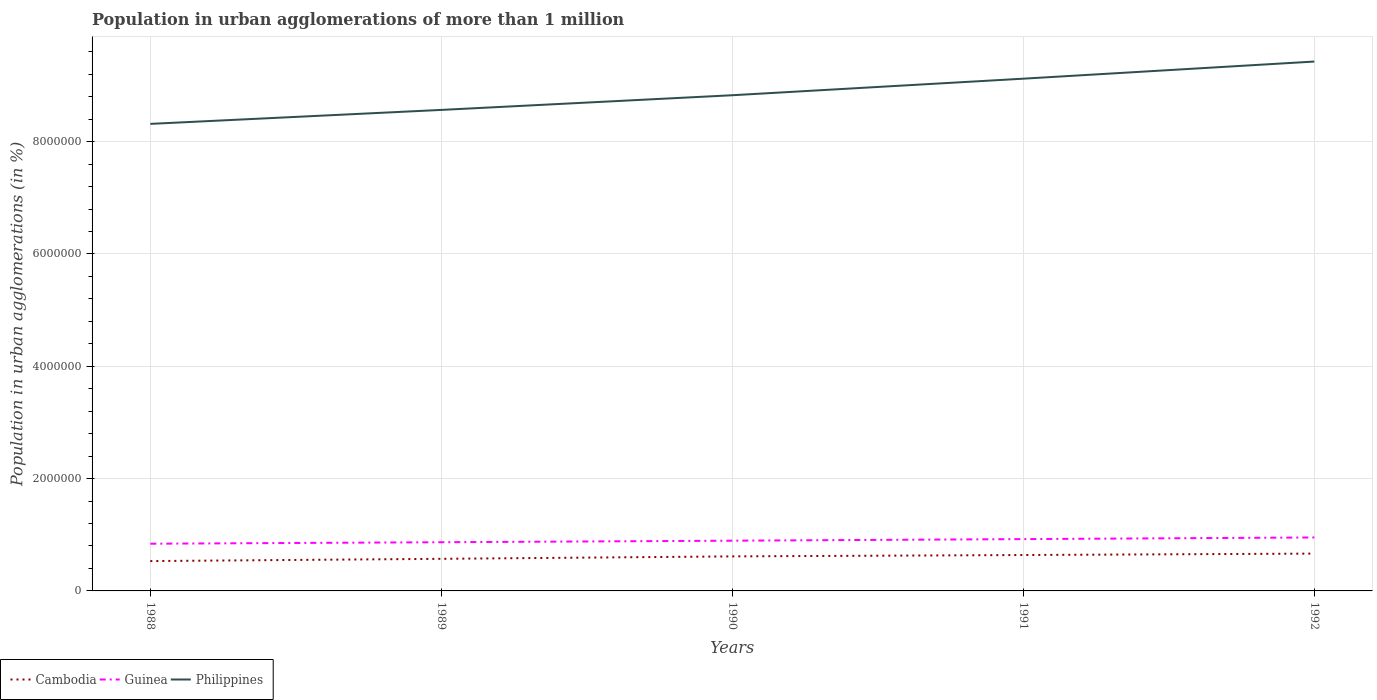How many different coloured lines are there?
Offer a very short reply. 3. Across all years, what is the maximum population in urban agglomerations in Guinea?
Make the answer very short. 8.41e+05. In which year was the population in urban agglomerations in Cambodia maximum?
Keep it short and to the point. 1988. What is the total population in urban agglomerations in Philippines in the graph?
Make the answer very short. -5.56e+05. What is the difference between the highest and the second highest population in urban agglomerations in Guinea?
Your answer should be compact. 1.11e+05. How many lines are there?
Offer a terse response. 3. How many years are there in the graph?
Your answer should be very brief. 5. What is the difference between two consecutive major ticks on the Y-axis?
Give a very brief answer. 2.00e+06. Are the values on the major ticks of Y-axis written in scientific E-notation?
Ensure brevity in your answer.  No. Does the graph contain any zero values?
Offer a terse response. No. How many legend labels are there?
Your response must be concise. 3. How are the legend labels stacked?
Offer a very short reply. Horizontal. What is the title of the graph?
Your answer should be very brief. Population in urban agglomerations of more than 1 million. What is the label or title of the X-axis?
Your response must be concise. Years. What is the label or title of the Y-axis?
Make the answer very short. Population in urban agglomerations (in %). What is the Population in urban agglomerations (in %) of Cambodia in 1988?
Your response must be concise. 5.32e+05. What is the Population in urban agglomerations (in %) in Guinea in 1988?
Provide a short and direct response. 8.41e+05. What is the Population in urban agglomerations (in %) of Philippines in 1988?
Your answer should be compact. 8.32e+06. What is the Population in urban agglomerations (in %) in Cambodia in 1989?
Give a very brief answer. 5.72e+05. What is the Population in urban agglomerations (in %) of Guinea in 1989?
Your answer should be compact. 8.67e+05. What is the Population in urban agglomerations (in %) of Philippines in 1989?
Give a very brief answer. 8.57e+06. What is the Population in urban agglomerations (in %) in Cambodia in 1990?
Keep it short and to the point. 6.15e+05. What is the Population in urban agglomerations (in %) of Guinea in 1990?
Provide a short and direct response. 8.95e+05. What is the Population in urban agglomerations (in %) in Philippines in 1990?
Keep it short and to the point. 8.83e+06. What is the Population in urban agglomerations (in %) in Cambodia in 1991?
Make the answer very short. 6.39e+05. What is the Population in urban agglomerations (in %) of Guinea in 1991?
Give a very brief answer. 9.23e+05. What is the Population in urban agglomerations (in %) of Philippines in 1991?
Keep it short and to the point. 9.12e+06. What is the Population in urban agglomerations (in %) in Cambodia in 1992?
Your response must be concise. 6.65e+05. What is the Population in urban agglomerations (in %) of Guinea in 1992?
Make the answer very short. 9.52e+05. What is the Population in urban agglomerations (in %) of Philippines in 1992?
Offer a very short reply. 9.43e+06. Across all years, what is the maximum Population in urban agglomerations (in %) in Cambodia?
Provide a succinct answer. 6.65e+05. Across all years, what is the maximum Population in urban agglomerations (in %) in Guinea?
Offer a terse response. 9.52e+05. Across all years, what is the maximum Population in urban agglomerations (in %) of Philippines?
Make the answer very short. 9.43e+06. Across all years, what is the minimum Population in urban agglomerations (in %) of Cambodia?
Provide a succinct answer. 5.32e+05. Across all years, what is the minimum Population in urban agglomerations (in %) in Guinea?
Your answer should be very brief. 8.41e+05. Across all years, what is the minimum Population in urban agglomerations (in %) in Philippines?
Offer a very short reply. 8.32e+06. What is the total Population in urban agglomerations (in %) of Cambodia in the graph?
Ensure brevity in your answer.  3.02e+06. What is the total Population in urban agglomerations (in %) of Guinea in the graph?
Provide a succinct answer. 4.48e+06. What is the total Population in urban agglomerations (in %) in Philippines in the graph?
Provide a short and direct response. 4.43e+07. What is the difference between the Population in urban agglomerations (in %) of Cambodia in 1988 and that in 1989?
Ensure brevity in your answer.  -4.02e+04. What is the difference between the Population in urban agglomerations (in %) in Guinea in 1988 and that in 1989?
Offer a terse response. -2.65e+04. What is the difference between the Population in urban agglomerations (in %) in Philippines in 1988 and that in 1989?
Provide a succinct answer. -2.49e+05. What is the difference between the Population in urban agglomerations (in %) in Cambodia in 1988 and that in 1990?
Give a very brief answer. -8.35e+04. What is the difference between the Population in urban agglomerations (in %) of Guinea in 1988 and that in 1990?
Keep it short and to the point. -5.39e+04. What is the difference between the Population in urban agglomerations (in %) of Philippines in 1988 and that in 1990?
Keep it short and to the point. -5.10e+05. What is the difference between the Population in urban agglomerations (in %) of Cambodia in 1988 and that in 1991?
Your response must be concise. -1.08e+05. What is the difference between the Population in urban agglomerations (in %) of Guinea in 1988 and that in 1991?
Make the answer very short. -8.22e+04. What is the difference between the Population in urban agglomerations (in %) of Philippines in 1988 and that in 1991?
Offer a terse response. -8.05e+05. What is the difference between the Population in urban agglomerations (in %) in Cambodia in 1988 and that in 1992?
Make the answer very short. -1.33e+05. What is the difference between the Population in urban agglomerations (in %) of Guinea in 1988 and that in 1992?
Offer a very short reply. -1.11e+05. What is the difference between the Population in urban agglomerations (in %) in Philippines in 1988 and that in 1992?
Offer a terse response. -1.11e+06. What is the difference between the Population in urban agglomerations (in %) in Cambodia in 1989 and that in 1990?
Ensure brevity in your answer.  -4.33e+04. What is the difference between the Population in urban agglomerations (in %) of Guinea in 1989 and that in 1990?
Keep it short and to the point. -2.74e+04. What is the difference between the Population in urban agglomerations (in %) in Philippines in 1989 and that in 1990?
Keep it short and to the point. -2.61e+05. What is the difference between the Population in urban agglomerations (in %) in Cambodia in 1989 and that in 1991?
Make the answer very short. -6.76e+04. What is the difference between the Population in urban agglomerations (in %) of Guinea in 1989 and that in 1991?
Your answer should be very brief. -5.57e+04. What is the difference between the Population in urban agglomerations (in %) of Philippines in 1989 and that in 1991?
Give a very brief answer. -5.56e+05. What is the difference between the Population in urban agglomerations (in %) of Cambodia in 1989 and that in 1992?
Offer a terse response. -9.30e+04. What is the difference between the Population in urban agglomerations (in %) of Guinea in 1989 and that in 1992?
Give a very brief answer. -8.49e+04. What is the difference between the Population in urban agglomerations (in %) in Philippines in 1989 and that in 1992?
Offer a terse response. -8.61e+05. What is the difference between the Population in urban agglomerations (in %) in Cambodia in 1990 and that in 1991?
Your answer should be compact. -2.44e+04. What is the difference between the Population in urban agglomerations (in %) in Guinea in 1990 and that in 1991?
Your answer should be compact. -2.83e+04. What is the difference between the Population in urban agglomerations (in %) of Philippines in 1990 and that in 1991?
Keep it short and to the point. -2.95e+05. What is the difference between the Population in urban agglomerations (in %) in Cambodia in 1990 and that in 1992?
Offer a terse response. -4.97e+04. What is the difference between the Population in urban agglomerations (in %) in Guinea in 1990 and that in 1992?
Provide a short and direct response. -5.75e+04. What is the difference between the Population in urban agglomerations (in %) in Philippines in 1990 and that in 1992?
Your answer should be very brief. -6.00e+05. What is the difference between the Population in urban agglomerations (in %) in Cambodia in 1991 and that in 1992?
Ensure brevity in your answer.  -2.54e+04. What is the difference between the Population in urban agglomerations (in %) of Guinea in 1991 and that in 1992?
Provide a short and direct response. -2.92e+04. What is the difference between the Population in urban agglomerations (in %) of Philippines in 1991 and that in 1992?
Your response must be concise. -3.05e+05. What is the difference between the Population in urban agglomerations (in %) of Cambodia in 1988 and the Population in urban agglomerations (in %) of Guinea in 1989?
Offer a very short reply. -3.36e+05. What is the difference between the Population in urban agglomerations (in %) of Cambodia in 1988 and the Population in urban agglomerations (in %) of Philippines in 1989?
Offer a very short reply. -8.03e+06. What is the difference between the Population in urban agglomerations (in %) of Guinea in 1988 and the Population in urban agglomerations (in %) of Philippines in 1989?
Offer a very short reply. -7.73e+06. What is the difference between the Population in urban agglomerations (in %) of Cambodia in 1988 and the Population in urban agglomerations (in %) of Guinea in 1990?
Your answer should be very brief. -3.63e+05. What is the difference between the Population in urban agglomerations (in %) in Cambodia in 1988 and the Population in urban agglomerations (in %) in Philippines in 1990?
Make the answer very short. -8.30e+06. What is the difference between the Population in urban agglomerations (in %) of Guinea in 1988 and the Population in urban agglomerations (in %) of Philippines in 1990?
Your answer should be very brief. -7.99e+06. What is the difference between the Population in urban agglomerations (in %) of Cambodia in 1988 and the Population in urban agglomerations (in %) of Guinea in 1991?
Make the answer very short. -3.91e+05. What is the difference between the Population in urban agglomerations (in %) of Cambodia in 1988 and the Population in urban agglomerations (in %) of Philippines in 1991?
Keep it short and to the point. -8.59e+06. What is the difference between the Population in urban agglomerations (in %) of Guinea in 1988 and the Population in urban agglomerations (in %) of Philippines in 1991?
Your answer should be very brief. -8.28e+06. What is the difference between the Population in urban agglomerations (in %) in Cambodia in 1988 and the Population in urban agglomerations (in %) in Guinea in 1992?
Your response must be concise. -4.20e+05. What is the difference between the Population in urban agglomerations (in %) of Cambodia in 1988 and the Population in urban agglomerations (in %) of Philippines in 1992?
Make the answer very short. -8.90e+06. What is the difference between the Population in urban agglomerations (in %) in Guinea in 1988 and the Population in urban agglomerations (in %) in Philippines in 1992?
Keep it short and to the point. -8.59e+06. What is the difference between the Population in urban agglomerations (in %) of Cambodia in 1989 and the Population in urban agglomerations (in %) of Guinea in 1990?
Offer a very short reply. -3.23e+05. What is the difference between the Population in urban agglomerations (in %) in Cambodia in 1989 and the Population in urban agglomerations (in %) in Philippines in 1990?
Ensure brevity in your answer.  -8.26e+06. What is the difference between the Population in urban agglomerations (in %) in Guinea in 1989 and the Population in urban agglomerations (in %) in Philippines in 1990?
Make the answer very short. -7.96e+06. What is the difference between the Population in urban agglomerations (in %) in Cambodia in 1989 and the Population in urban agglomerations (in %) in Guinea in 1991?
Provide a short and direct response. -3.51e+05. What is the difference between the Population in urban agglomerations (in %) of Cambodia in 1989 and the Population in urban agglomerations (in %) of Philippines in 1991?
Keep it short and to the point. -8.55e+06. What is the difference between the Population in urban agglomerations (in %) in Guinea in 1989 and the Population in urban agglomerations (in %) in Philippines in 1991?
Offer a very short reply. -8.25e+06. What is the difference between the Population in urban agglomerations (in %) of Cambodia in 1989 and the Population in urban agglomerations (in %) of Guinea in 1992?
Provide a short and direct response. -3.80e+05. What is the difference between the Population in urban agglomerations (in %) in Cambodia in 1989 and the Population in urban agglomerations (in %) in Philippines in 1992?
Your answer should be very brief. -8.86e+06. What is the difference between the Population in urban agglomerations (in %) of Guinea in 1989 and the Population in urban agglomerations (in %) of Philippines in 1992?
Offer a terse response. -8.56e+06. What is the difference between the Population in urban agglomerations (in %) in Cambodia in 1990 and the Population in urban agglomerations (in %) in Guinea in 1991?
Offer a terse response. -3.08e+05. What is the difference between the Population in urban agglomerations (in %) in Cambodia in 1990 and the Population in urban agglomerations (in %) in Philippines in 1991?
Ensure brevity in your answer.  -8.51e+06. What is the difference between the Population in urban agglomerations (in %) of Guinea in 1990 and the Population in urban agglomerations (in %) of Philippines in 1991?
Offer a very short reply. -8.23e+06. What is the difference between the Population in urban agglomerations (in %) of Cambodia in 1990 and the Population in urban agglomerations (in %) of Guinea in 1992?
Keep it short and to the point. -3.37e+05. What is the difference between the Population in urban agglomerations (in %) of Cambodia in 1990 and the Population in urban agglomerations (in %) of Philippines in 1992?
Provide a succinct answer. -8.81e+06. What is the difference between the Population in urban agglomerations (in %) in Guinea in 1990 and the Population in urban agglomerations (in %) in Philippines in 1992?
Provide a short and direct response. -8.53e+06. What is the difference between the Population in urban agglomerations (in %) in Cambodia in 1991 and the Population in urban agglomerations (in %) in Guinea in 1992?
Your answer should be very brief. -3.13e+05. What is the difference between the Population in urban agglomerations (in %) in Cambodia in 1991 and the Population in urban agglomerations (in %) in Philippines in 1992?
Your answer should be very brief. -8.79e+06. What is the difference between the Population in urban agglomerations (in %) of Guinea in 1991 and the Population in urban agglomerations (in %) of Philippines in 1992?
Your answer should be compact. -8.50e+06. What is the average Population in urban agglomerations (in %) in Cambodia per year?
Ensure brevity in your answer.  6.04e+05. What is the average Population in urban agglomerations (in %) of Guinea per year?
Your answer should be compact. 8.95e+05. What is the average Population in urban agglomerations (in %) of Philippines per year?
Give a very brief answer. 8.85e+06. In the year 1988, what is the difference between the Population in urban agglomerations (in %) in Cambodia and Population in urban agglomerations (in %) in Guinea?
Ensure brevity in your answer.  -3.09e+05. In the year 1988, what is the difference between the Population in urban agglomerations (in %) of Cambodia and Population in urban agglomerations (in %) of Philippines?
Ensure brevity in your answer.  -7.79e+06. In the year 1988, what is the difference between the Population in urban agglomerations (in %) in Guinea and Population in urban agglomerations (in %) in Philippines?
Give a very brief answer. -7.48e+06. In the year 1989, what is the difference between the Population in urban agglomerations (in %) of Cambodia and Population in urban agglomerations (in %) of Guinea?
Provide a short and direct response. -2.95e+05. In the year 1989, what is the difference between the Population in urban agglomerations (in %) of Cambodia and Population in urban agglomerations (in %) of Philippines?
Offer a very short reply. -7.99e+06. In the year 1989, what is the difference between the Population in urban agglomerations (in %) in Guinea and Population in urban agglomerations (in %) in Philippines?
Provide a succinct answer. -7.70e+06. In the year 1990, what is the difference between the Population in urban agglomerations (in %) in Cambodia and Population in urban agglomerations (in %) in Guinea?
Keep it short and to the point. -2.80e+05. In the year 1990, what is the difference between the Population in urban agglomerations (in %) of Cambodia and Population in urban agglomerations (in %) of Philippines?
Make the answer very short. -8.21e+06. In the year 1990, what is the difference between the Population in urban agglomerations (in %) of Guinea and Population in urban agglomerations (in %) of Philippines?
Keep it short and to the point. -7.93e+06. In the year 1991, what is the difference between the Population in urban agglomerations (in %) of Cambodia and Population in urban agglomerations (in %) of Guinea?
Keep it short and to the point. -2.83e+05. In the year 1991, what is the difference between the Population in urban agglomerations (in %) in Cambodia and Population in urban agglomerations (in %) in Philippines?
Offer a very short reply. -8.48e+06. In the year 1991, what is the difference between the Population in urban agglomerations (in %) in Guinea and Population in urban agglomerations (in %) in Philippines?
Your response must be concise. -8.20e+06. In the year 1992, what is the difference between the Population in urban agglomerations (in %) in Cambodia and Population in urban agglomerations (in %) in Guinea?
Provide a short and direct response. -2.87e+05. In the year 1992, what is the difference between the Population in urban agglomerations (in %) in Cambodia and Population in urban agglomerations (in %) in Philippines?
Provide a succinct answer. -8.76e+06. In the year 1992, what is the difference between the Population in urban agglomerations (in %) in Guinea and Population in urban agglomerations (in %) in Philippines?
Offer a terse response. -8.47e+06. What is the ratio of the Population in urban agglomerations (in %) in Cambodia in 1988 to that in 1989?
Make the answer very short. 0.93. What is the ratio of the Population in urban agglomerations (in %) of Guinea in 1988 to that in 1989?
Keep it short and to the point. 0.97. What is the ratio of the Population in urban agglomerations (in %) in Cambodia in 1988 to that in 1990?
Give a very brief answer. 0.86. What is the ratio of the Population in urban agglomerations (in %) in Guinea in 1988 to that in 1990?
Ensure brevity in your answer.  0.94. What is the ratio of the Population in urban agglomerations (in %) of Philippines in 1988 to that in 1990?
Provide a short and direct response. 0.94. What is the ratio of the Population in urban agglomerations (in %) of Cambodia in 1988 to that in 1991?
Provide a short and direct response. 0.83. What is the ratio of the Population in urban agglomerations (in %) of Guinea in 1988 to that in 1991?
Provide a succinct answer. 0.91. What is the ratio of the Population in urban agglomerations (in %) in Philippines in 1988 to that in 1991?
Your response must be concise. 0.91. What is the ratio of the Population in urban agglomerations (in %) in Cambodia in 1988 to that in 1992?
Make the answer very short. 0.8. What is the ratio of the Population in urban agglomerations (in %) in Guinea in 1988 to that in 1992?
Offer a very short reply. 0.88. What is the ratio of the Population in urban agglomerations (in %) in Philippines in 1988 to that in 1992?
Offer a very short reply. 0.88. What is the ratio of the Population in urban agglomerations (in %) of Cambodia in 1989 to that in 1990?
Give a very brief answer. 0.93. What is the ratio of the Population in urban agglomerations (in %) in Guinea in 1989 to that in 1990?
Provide a short and direct response. 0.97. What is the ratio of the Population in urban agglomerations (in %) of Philippines in 1989 to that in 1990?
Give a very brief answer. 0.97. What is the ratio of the Population in urban agglomerations (in %) in Cambodia in 1989 to that in 1991?
Ensure brevity in your answer.  0.89. What is the ratio of the Population in urban agglomerations (in %) of Guinea in 1989 to that in 1991?
Keep it short and to the point. 0.94. What is the ratio of the Population in urban agglomerations (in %) in Philippines in 1989 to that in 1991?
Give a very brief answer. 0.94. What is the ratio of the Population in urban agglomerations (in %) of Cambodia in 1989 to that in 1992?
Give a very brief answer. 0.86. What is the ratio of the Population in urban agglomerations (in %) of Guinea in 1989 to that in 1992?
Offer a very short reply. 0.91. What is the ratio of the Population in urban agglomerations (in %) of Philippines in 1989 to that in 1992?
Ensure brevity in your answer.  0.91. What is the ratio of the Population in urban agglomerations (in %) in Cambodia in 1990 to that in 1991?
Give a very brief answer. 0.96. What is the ratio of the Population in urban agglomerations (in %) of Guinea in 1990 to that in 1991?
Your response must be concise. 0.97. What is the ratio of the Population in urban agglomerations (in %) in Cambodia in 1990 to that in 1992?
Ensure brevity in your answer.  0.93. What is the ratio of the Population in urban agglomerations (in %) in Guinea in 1990 to that in 1992?
Your answer should be compact. 0.94. What is the ratio of the Population in urban agglomerations (in %) in Philippines in 1990 to that in 1992?
Ensure brevity in your answer.  0.94. What is the ratio of the Population in urban agglomerations (in %) in Cambodia in 1991 to that in 1992?
Provide a succinct answer. 0.96. What is the ratio of the Population in urban agglomerations (in %) of Guinea in 1991 to that in 1992?
Ensure brevity in your answer.  0.97. What is the ratio of the Population in urban agglomerations (in %) in Philippines in 1991 to that in 1992?
Provide a short and direct response. 0.97. What is the difference between the highest and the second highest Population in urban agglomerations (in %) in Cambodia?
Provide a succinct answer. 2.54e+04. What is the difference between the highest and the second highest Population in urban agglomerations (in %) of Guinea?
Your answer should be very brief. 2.92e+04. What is the difference between the highest and the second highest Population in urban agglomerations (in %) of Philippines?
Offer a very short reply. 3.05e+05. What is the difference between the highest and the lowest Population in urban agglomerations (in %) of Cambodia?
Provide a succinct answer. 1.33e+05. What is the difference between the highest and the lowest Population in urban agglomerations (in %) of Guinea?
Your answer should be very brief. 1.11e+05. What is the difference between the highest and the lowest Population in urban agglomerations (in %) of Philippines?
Make the answer very short. 1.11e+06. 